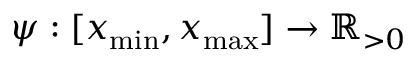Convert formula to latex. <formula><loc_0><loc_0><loc_500><loc_500>\psi \colon [ x _ { \min } , x _ { \max } ] \to \mathbb { R } _ { > 0 }</formula> 